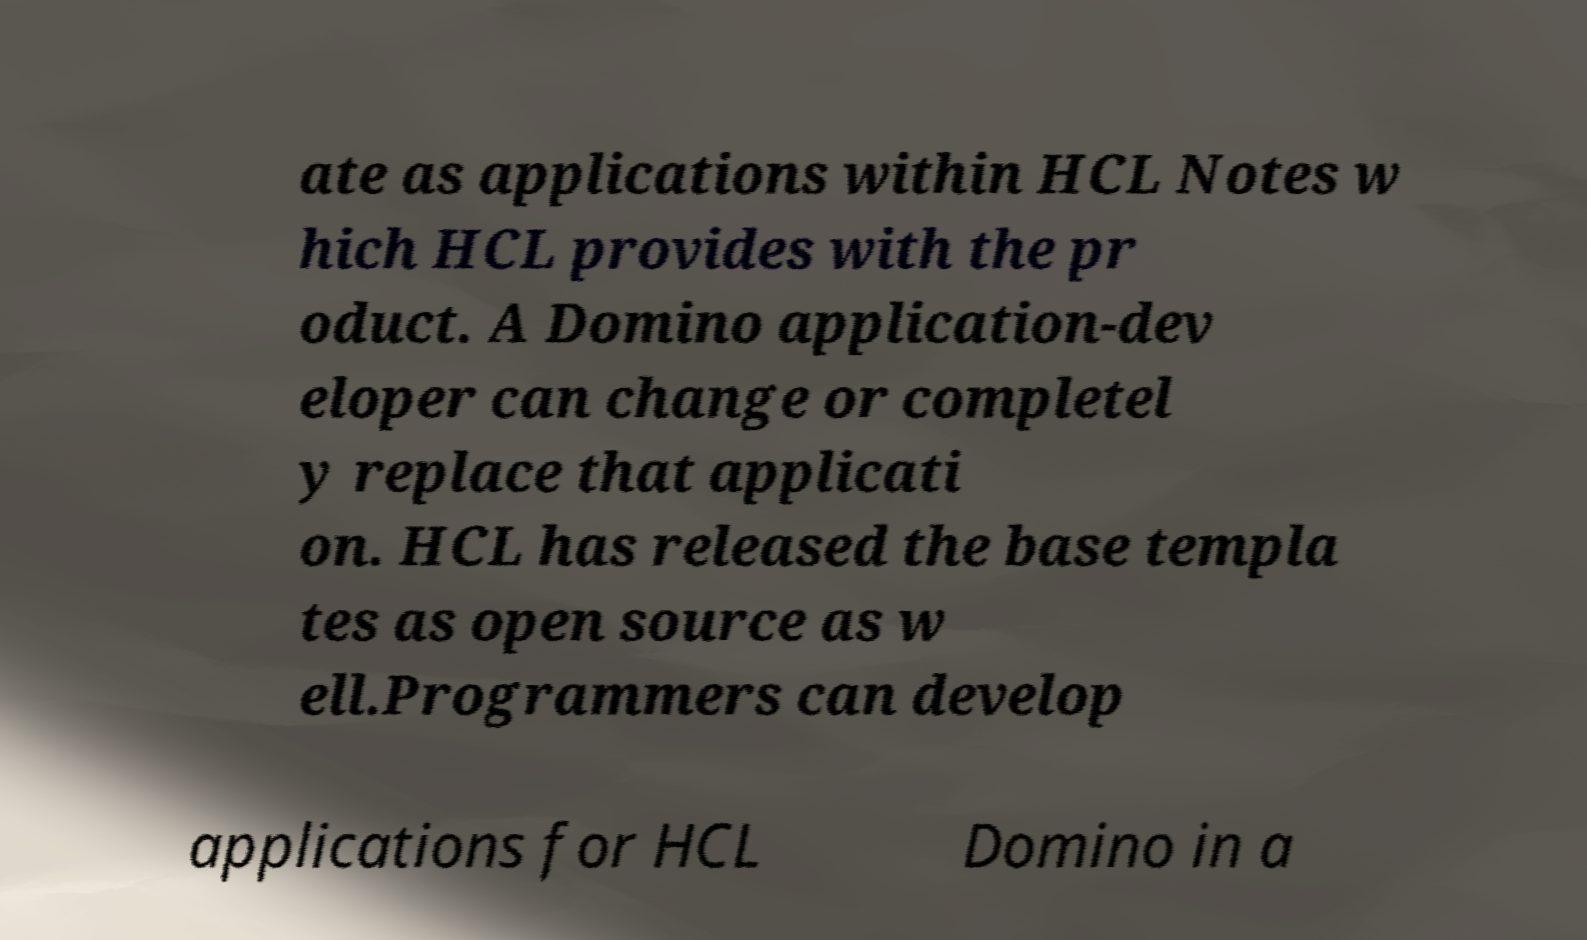There's text embedded in this image that I need extracted. Can you transcribe it verbatim? ate as applications within HCL Notes w hich HCL provides with the pr oduct. A Domino application-dev eloper can change or completel y replace that applicati on. HCL has released the base templa tes as open source as w ell.Programmers can develop applications for HCL Domino in a 